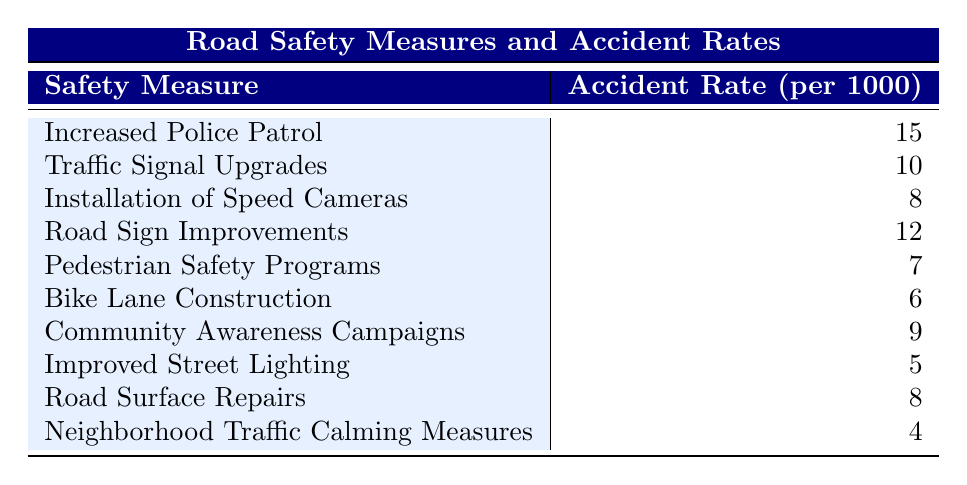What is the accident rate for Neighborhood Traffic Calming Measures? The table directly states that the accident rate for Neighborhood Traffic Calming Measures is presented alongside the measure itself.
Answer: 4 Which road safety measure has the highest accident rate? By examining the accident rates listed in the table, Increased Police Patrol shows the highest value at 15.
Answer: Increased Police Patrol How many road safety measures have an accident rate below 10? We can count the measures with rates below 10: Installation of Speed Cameras (8), Pedestrian Safety Programs (7), Bike Lane Construction (6), Improved Street Lighting (5), and Neighborhood Traffic Calming Measures (4). This gives us a total of 5.
Answer: 5 What is the average accident rate of the measures that include "Speed"? The measures that include "Speed" are Installation of Speed Cameras (8) and Improved Street Lighting (5). The average is (8 + 5) / 2 = 6.5.
Answer: 6.5 Is the accident rate for Community Awareness Campaigns greater than that for Bike Lane Construction? By comparing the accident rates from the table, Community Awareness Campaigns has an accident rate of 9, while Bike Lane Construction has 6. Since 9 is greater than 6, the statement is true.
Answer: Yes What is the difference in accident rates between Road Sign Improvements and Traffic Signal Upgrades? Road Sign Improvements has an accident rate of 12, and Traffic Signal Upgrades has an accident rate of 10. Therefore, the difference is 12 - 10 = 2.
Answer: 2 How many of the road safety measures have an accident rate of 8 or higher? Listing the measures: Increased Police Patrol (15), Traffic Signal Upgrades (10), Road Sign Improvements (12), Installation of Speed Cameras (8), and Road Surface Repairs (8), we find a total of 5 measures.
Answer: 5 What is the sum of the accident rates for the top three measures? The top three measures by accident rate are Increased Police Patrol (15), Road Sign Improvements (12), and Traffic Signal Upgrades (10). Their sum is 15 + 12 + 10 = 37.
Answer: 37 Is there any measure that has an accident rate of exactly 6? The table shows that Bike Lane Construction has an accident rate of 6, confirming this statement is true.
Answer: Yes 